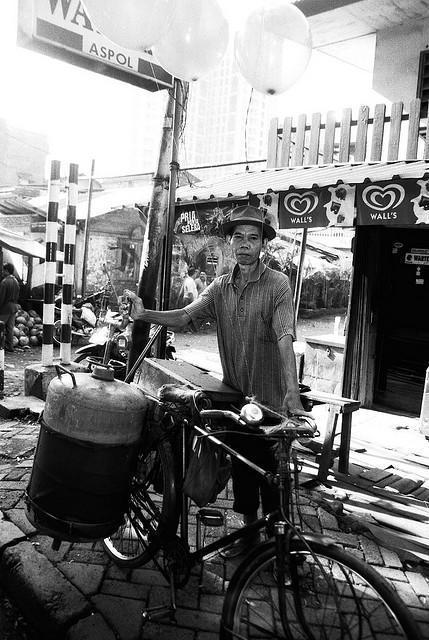What is the shape of the Wall's logo?
Pick the correct solution from the four options below to address the question.
Options: Circle, square, heart, triangle. Heart. 